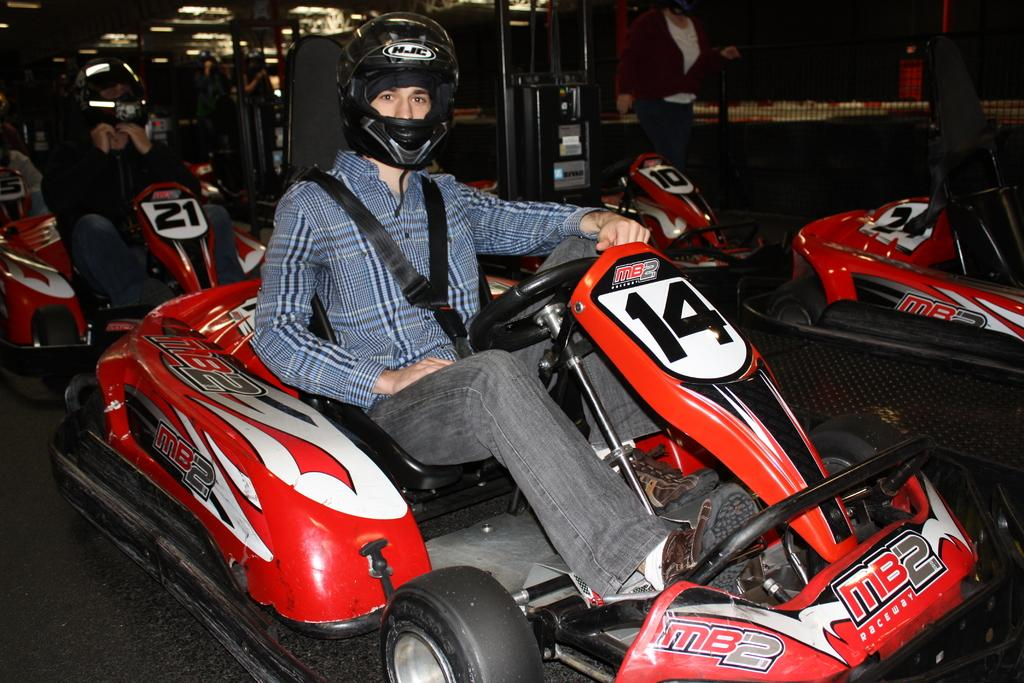What are the two persons in the middle of the image doing? The two persons are sitting on vehicles in the middle of the image. Are there any other vehicles visible in the image? Yes, there are additional vehicles beside the ones with people sitting on them. Can you describe the person at the top of the image? There is a person standing at the top of the image. What type of star can be seen shining brightly in the image? There is no star visible in the image; it is focused on vehicles and people. 